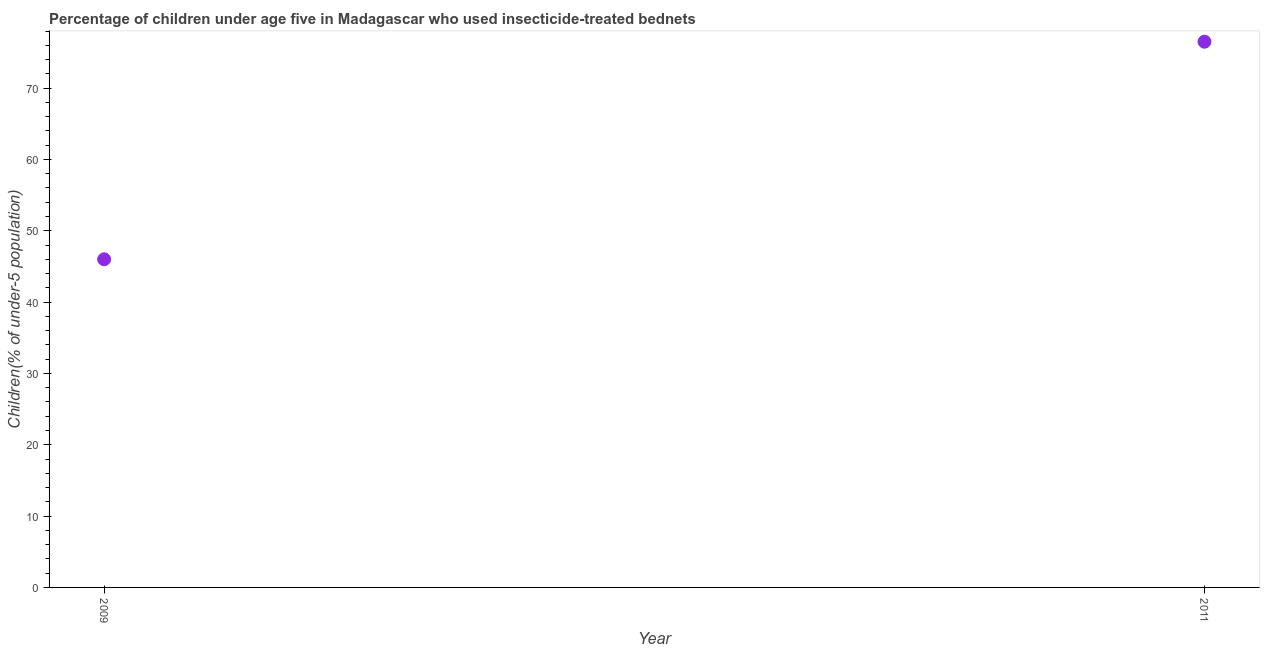What is the percentage of children who use of insecticide-treated bed nets in 2009?
Ensure brevity in your answer.  46. Across all years, what is the maximum percentage of children who use of insecticide-treated bed nets?
Your answer should be very brief. 76.5. Across all years, what is the minimum percentage of children who use of insecticide-treated bed nets?
Offer a terse response. 46. In which year was the percentage of children who use of insecticide-treated bed nets minimum?
Offer a very short reply. 2009. What is the sum of the percentage of children who use of insecticide-treated bed nets?
Offer a terse response. 122.5. What is the difference between the percentage of children who use of insecticide-treated bed nets in 2009 and 2011?
Your answer should be compact. -30.5. What is the average percentage of children who use of insecticide-treated bed nets per year?
Ensure brevity in your answer.  61.25. What is the median percentage of children who use of insecticide-treated bed nets?
Offer a very short reply. 61.25. In how many years, is the percentage of children who use of insecticide-treated bed nets greater than 34 %?
Provide a short and direct response. 2. Do a majority of the years between 2009 and 2011 (inclusive) have percentage of children who use of insecticide-treated bed nets greater than 4 %?
Provide a succinct answer. Yes. What is the ratio of the percentage of children who use of insecticide-treated bed nets in 2009 to that in 2011?
Ensure brevity in your answer.  0.6. How many dotlines are there?
Your answer should be compact. 1. How many years are there in the graph?
Make the answer very short. 2. What is the difference between two consecutive major ticks on the Y-axis?
Give a very brief answer. 10. Are the values on the major ticks of Y-axis written in scientific E-notation?
Offer a terse response. No. Does the graph contain grids?
Offer a terse response. No. What is the title of the graph?
Provide a short and direct response. Percentage of children under age five in Madagascar who used insecticide-treated bednets. What is the label or title of the X-axis?
Your answer should be very brief. Year. What is the label or title of the Y-axis?
Ensure brevity in your answer.  Children(% of under-5 population). What is the Children(% of under-5 population) in 2009?
Give a very brief answer. 46. What is the Children(% of under-5 population) in 2011?
Offer a very short reply. 76.5. What is the difference between the Children(% of under-5 population) in 2009 and 2011?
Offer a very short reply. -30.5. What is the ratio of the Children(% of under-5 population) in 2009 to that in 2011?
Provide a short and direct response. 0.6. 